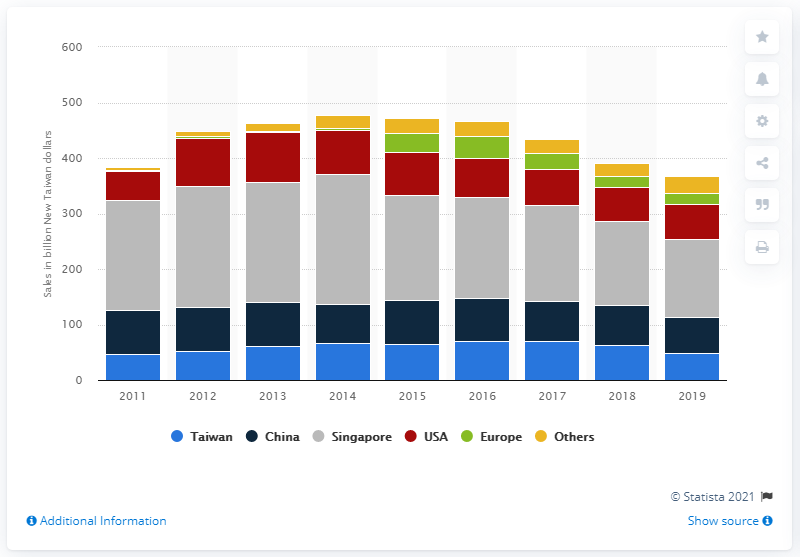Draw attention to some important aspects in this diagram. The region that generated the largest revenues was Singapore. Asus' revenue in China in 2019 was 64.37 billion yuan. In 2019, Asus' revenue in the United States was 62.16 million dollars. 